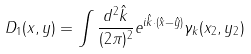<formula> <loc_0><loc_0><loc_500><loc_500>D _ { 1 } ( x , y ) = \int \frac { d ^ { 2 } \hat { k } } { ( 2 \pi ) ^ { 2 } } e ^ { i \hat { k } \cdot ( \hat { x } - \hat { y } ) } \gamma _ { k } ( x _ { 2 } , y _ { 2 } )</formula> 